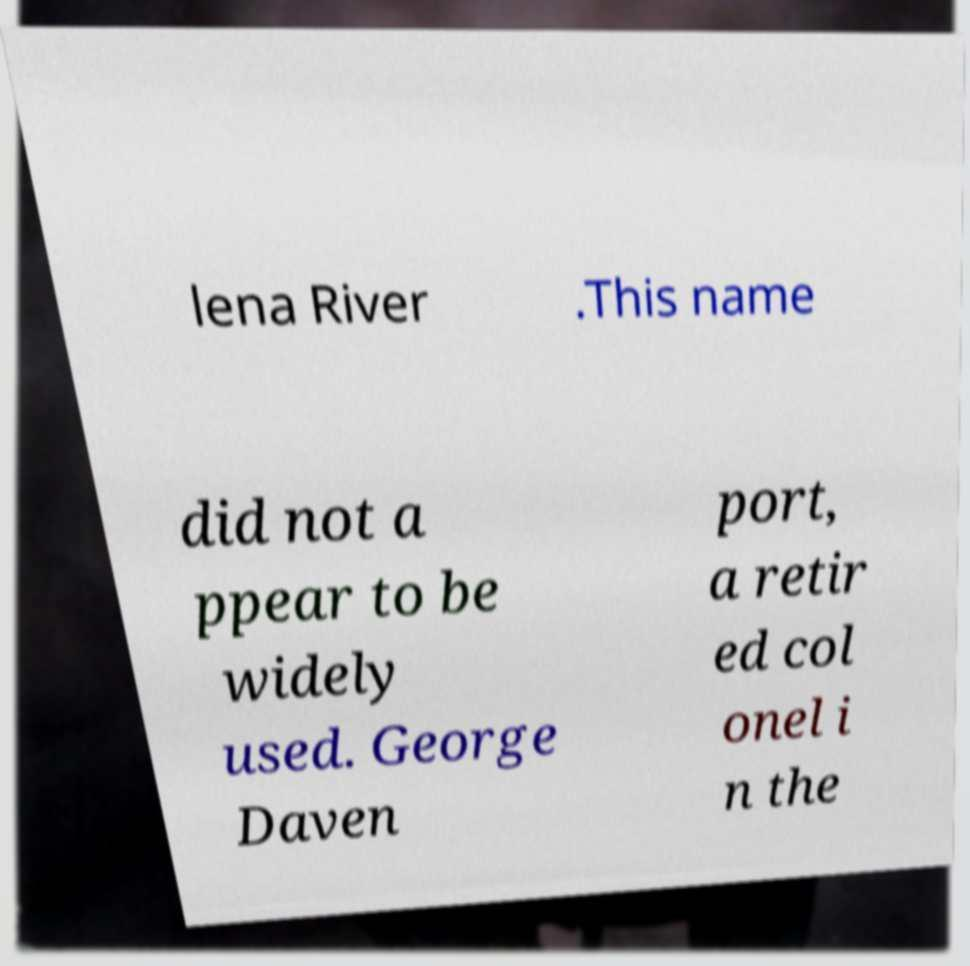Can you read and provide the text displayed in the image?This photo seems to have some interesting text. Can you extract and type it out for me? lena River .This name did not a ppear to be widely used. George Daven port, a retir ed col onel i n the 